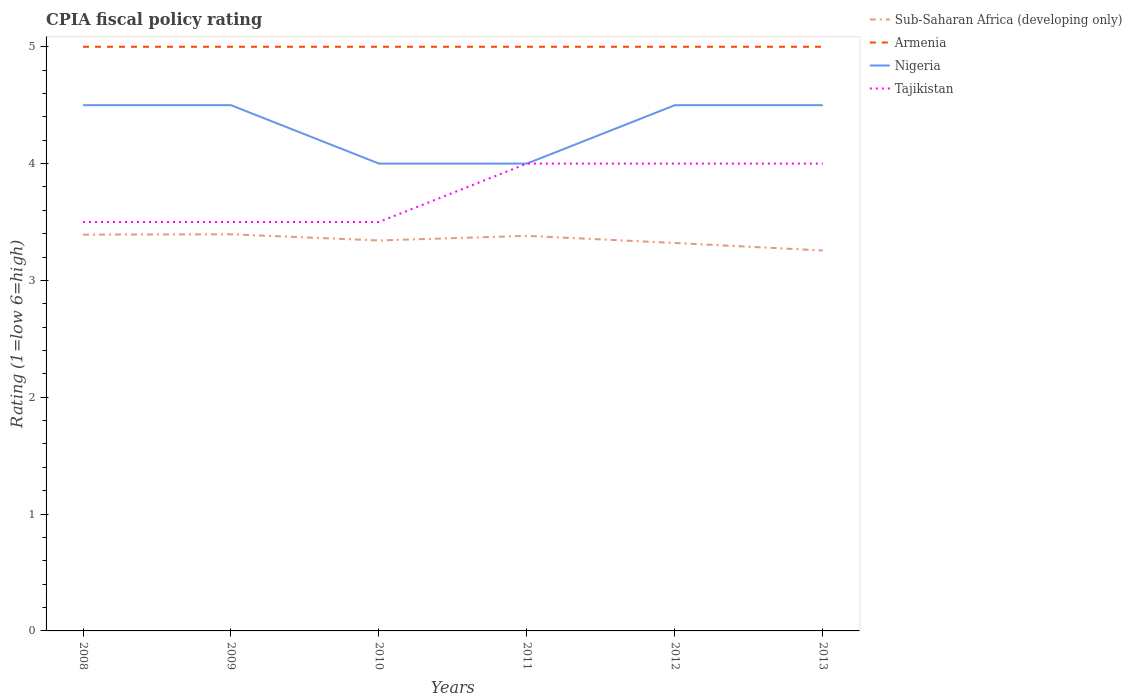How many different coloured lines are there?
Your answer should be compact. 4. Across all years, what is the maximum CPIA rating in Armenia?
Offer a very short reply. 5. In which year was the CPIA rating in Armenia maximum?
Give a very brief answer. 2008. What is the total CPIA rating in Sub-Saharan Africa (developing only) in the graph?
Provide a short and direct response. 0.13. What is the difference between the highest and the second highest CPIA rating in Tajikistan?
Your response must be concise. 0.5. What is the difference between the highest and the lowest CPIA rating in Tajikistan?
Offer a terse response. 3. How many lines are there?
Your answer should be compact. 4. How many years are there in the graph?
Keep it short and to the point. 6. What is the difference between two consecutive major ticks on the Y-axis?
Offer a very short reply. 1. Are the values on the major ticks of Y-axis written in scientific E-notation?
Ensure brevity in your answer.  No. How many legend labels are there?
Provide a short and direct response. 4. How are the legend labels stacked?
Offer a very short reply. Vertical. What is the title of the graph?
Make the answer very short. CPIA fiscal policy rating. What is the label or title of the X-axis?
Offer a very short reply. Years. What is the label or title of the Y-axis?
Offer a terse response. Rating (1=low 6=high). What is the Rating (1=low 6=high) of Sub-Saharan Africa (developing only) in 2008?
Your response must be concise. 3.39. What is the Rating (1=low 6=high) of Armenia in 2008?
Your response must be concise. 5. What is the Rating (1=low 6=high) of Sub-Saharan Africa (developing only) in 2009?
Your answer should be compact. 3.39. What is the Rating (1=low 6=high) of Armenia in 2009?
Your answer should be very brief. 5. What is the Rating (1=low 6=high) in Nigeria in 2009?
Your response must be concise. 4.5. What is the Rating (1=low 6=high) in Sub-Saharan Africa (developing only) in 2010?
Your response must be concise. 3.34. What is the Rating (1=low 6=high) of Sub-Saharan Africa (developing only) in 2011?
Your response must be concise. 3.38. What is the Rating (1=low 6=high) of Tajikistan in 2011?
Offer a very short reply. 4. What is the Rating (1=low 6=high) in Sub-Saharan Africa (developing only) in 2012?
Provide a short and direct response. 3.32. What is the Rating (1=low 6=high) of Armenia in 2012?
Your answer should be very brief. 5. What is the Rating (1=low 6=high) in Nigeria in 2012?
Provide a succinct answer. 4.5. What is the Rating (1=low 6=high) of Tajikistan in 2012?
Your response must be concise. 4. What is the Rating (1=low 6=high) in Sub-Saharan Africa (developing only) in 2013?
Offer a terse response. 3.26. What is the Rating (1=low 6=high) in Armenia in 2013?
Keep it short and to the point. 5. Across all years, what is the maximum Rating (1=low 6=high) in Sub-Saharan Africa (developing only)?
Your answer should be compact. 3.39. Across all years, what is the minimum Rating (1=low 6=high) in Sub-Saharan Africa (developing only)?
Ensure brevity in your answer.  3.26. Across all years, what is the minimum Rating (1=low 6=high) of Nigeria?
Your answer should be compact. 4. Across all years, what is the minimum Rating (1=low 6=high) of Tajikistan?
Your answer should be compact. 3.5. What is the total Rating (1=low 6=high) of Sub-Saharan Africa (developing only) in the graph?
Keep it short and to the point. 20.09. What is the total Rating (1=low 6=high) in Nigeria in the graph?
Your answer should be compact. 26. What is the total Rating (1=low 6=high) of Tajikistan in the graph?
Provide a succinct answer. 22.5. What is the difference between the Rating (1=low 6=high) in Sub-Saharan Africa (developing only) in 2008 and that in 2009?
Your response must be concise. -0. What is the difference between the Rating (1=low 6=high) in Nigeria in 2008 and that in 2009?
Your answer should be compact. 0. What is the difference between the Rating (1=low 6=high) in Tajikistan in 2008 and that in 2009?
Your response must be concise. 0. What is the difference between the Rating (1=low 6=high) of Sub-Saharan Africa (developing only) in 2008 and that in 2010?
Offer a terse response. 0.05. What is the difference between the Rating (1=low 6=high) in Armenia in 2008 and that in 2010?
Offer a very short reply. 0. What is the difference between the Rating (1=low 6=high) of Tajikistan in 2008 and that in 2010?
Offer a very short reply. 0. What is the difference between the Rating (1=low 6=high) of Sub-Saharan Africa (developing only) in 2008 and that in 2011?
Your answer should be compact. 0.01. What is the difference between the Rating (1=low 6=high) in Armenia in 2008 and that in 2011?
Your answer should be compact. 0. What is the difference between the Rating (1=low 6=high) of Sub-Saharan Africa (developing only) in 2008 and that in 2012?
Your response must be concise. 0.07. What is the difference between the Rating (1=low 6=high) in Sub-Saharan Africa (developing only) in 2008 and that in 2013?
Your answer should be very brief. 0.14. What is the difference between the Rating (1=low 6=high) in Armenia in 2008 and that in 2013?
Offer a terse response. 0. What is the difference between the Rating (1=low 6=high) in Tajikistan in 2008 and that in 2013?
Provide a short and direct response. -0.5. What is the difference between the Rating (1=low 6=high) of Sub-Saharan Africa (developing only) in 2009 and that in 2010?
Keep it short and to the point. 0.05. What is the difference between the Rating (1=low 6=high) of Nigeria in 2009 and that in 2010?
Your response must be concise. 0.5. What is the difference between the Rating (1=low 6=high) of Sub-Saharan Africa (developing only) in 2009 and that in 2011?
Your response must be concise. 0.01. What is the difference between the Rating (1=low 6=high) in Armenia in 2009 and that in 2011?
Provide a short and direct response. 0. What is the difference between the Rating (1=low 6=high) in Sub-Saharan Africa (developing only) in 2009 and that in 2012?
Your response must be concise. 0.07. What is the difference between the Rating (1=low 6=high) in Armenia in 2009 and that in 2012?
Your response must be concise. 0. What is the difference between the Rating (1=low 6=high) in Sub-Saharan Africa (developing only) in 2009 and that in 2013?
Offer a terse response. 0.14. What is the difference between the Rating (1=low 6=high) of Armenia in 2009 and that in 2013?
Your answer should be very brief. 0. What is the difference between the Rating (1=low 6=high) of Nigeria in 2009 and that in 2013?
Offer a terse response. 0. What is the difference between the Rating (1=low 6=high) of Tajikistan in 2009 and that in 2013?
Keep it short and to the point. -0.5. What is the difference between the Rating (1=low 6=high) of Sub-Saharan Africa (developing only) in 2010 and that in 2011?
Provide a short and direct response. -0.04. What is the difference between the Rating (1=low 6=high) in Sub-Saharan Africa (developing only) in 2010 and that in 2012?
Give a very brief answer. 0.02. What is the difference between the Rating (1=low 6=high) in Nigeria in 2010 and that in 2012?
Provide a succinct answer. -0.5. What is the difference between the Rating (1=low 6=high) in Tajikistan in 2010 and that in 2012?
Give a very brief answer. -0.5. What is the difference between the Rating (1=low 6=high) in Sub-Saharan Africa (developing only) in 2010 and that in 2013?
Your answer should be very brief. 0.09. What is the difference between the Rating (1=low 6=high) in Armenia in 2010 and that in 2013?
Keep it short and to the point. 0. What is the difference between the Rating (1=low 6=high) in Nigeria in 2010 and that in 2013?
Ensure brevity in your answer.  -0.5. What is the difference between the Rating (1=low 6=high) of Sub-Saharan Africa (developing only) in 2011 and that in 2012?
Your answer should be compact. 0.06. What is the difference between the Rating (1=low 6=high) of Nigeria in 2011 and that in 2012?
Keep it short and to the point. -0.5. What is the difference between the Rating (1=low 6=high) in Tajikistan in 2011 and that in 2012?
Ensure brevity in your answer.  0. What is the difference between the Rating (1=low 6=high) in Sub-Saharan Africa (developing only) in 2011 and that in 2013?
Your answer should be compact. 0.13. What is the difference between the Rating (1=low 6=high) of Sub-Saharan Africa (developing only) in 2012 and that in 2013?
Your answer should be very brief. 0.06. What is the difference between the Rating (1=low 6=high) of Armenia in 2012 and that in 2013?
Your answer should be very brief. 0. What is the difference between the Rating (1=low 6=high) in Sub-Saharan Africa (developing only) in 2008 and the Rating (1=low 6=high) in Armenia in 2009?
Make the answer very short. -1.61. What is the difference between the Rating (1=low 6=high) in Sub-Saharan Africa (developing only) in 2008 and the Rating (1=low 6=high) in Nigeria in 2009?
Offer a very short reply. -1.11. What is the difference between the Rating (1=low 6=high) of Sub-Saharan Africa (developing only) in 2008 and the Rating (1=low 6=high) of Tajikistan in 2009?
Provide a short and direct response. -0.11. What is the difference between the Rating (1=low 6=high) in Armenia in 2008 and the Rating (1=low 6=high) in Nigeria in 2009?
Your answer should be compact. 0.5. What is the difference between the Rating (1=low 6=high) in Sub-Saharan Africa (developing only) in 2008 and the Rating (1=low 6=high) in Armenia in 2010?
Offer a terse response. -1.61. What is the difference between the Rating (1=low 6=high) in Sub-Saharan Africa (developing only) in 2008 and the Rating (1=low 6=high) in Nigeria in 2010?
Ensure brevity in your answer.  -0.61. What is the difference between the Rating (1=low 6=high) of Sub-Saharan Africa (developing only) in 2008 and the Rating (1=low 6=high) of Tajikistan in 2010?
Your answer should be very brief. -0.11. What is the difference between the Rating (1=low 6=high) of Sub-Saharan Africa (developing only) in 2008 and the Rating (1=low 6=high) of Armenia in 2011?
Offer a very short reply. -1.61. What is the difference between the Rating (1=low 6=high) in Sub-Saharan Africa (developing only) in 2008 and the Rating (1=low 6=high) in Nigeria in 2011?
Offer a very short reply. -0.61. What is the difference between the Rating (1=low 6=high) of Sub-Saharan Africa (developing only) in 2008 and the Rating (1=low 6=high) of Tajikistan in 2011?
Provide a short and direct response. -0.61. What is the difference between the Rating (1=low 6=high) of Armenia in 2008 and the Rating (1=low 6=high) of Nigeria in 2011?
Provide a succinct answer. 1. What is the difference between the Rating (1=low 6=high) in Nigeria in 2008 and the Rating (1=low 6=high) in Tajikistan in 2011?
Offer a terse response. 0.5. What is the difference between the Rating (1=low 6=high) of Sub-Saharan Africa (developing only) in 2008 and the Rating (1=low 6=high) of Armenia in 2012?
Offer a terse response. -1.61. What is the difference between the Rating (1=low 6=high) of Sub-Saharan Africa (developing only) in 2008 and the Rating (1=low 6=high) of Nigeria in 2012?
Your answer should be compact. -1.11. What is the difference between the Rating (1=low 6=high) in Sub-Saharan Africa (developing only) in 2008 and the Rating (1=low 6=high) in Tajikistan in 2012?
Your answer should be compact. -0.61. What is the difference between the Rating (1=low 6=high) of Armenia in 2008 and the Rating (1=low 6=high) of Nigeria in 2012?
Provide a short and direct response. 0.5. What is the difference between the Rating (1=low 6=high) in Armenia in 2008 and the Rating (1=low 6=high) in Tajikistan in 2012?
Ensure brevity in your answer.  1. What is the difference between the Rating (1=low 6=high) of Sub-Saharan Africa (developing only) in 2008 and the Rating (1=low 6=high) of Armenia in 2013?
Ensure brevity in your answer.  -1.61. What is the difference between the Rating (1=low 6=high) of Sub-Saharan Africa (developing only) in 2008 and the Rating (1=low 6=high) of Nigeria in 2013?
Make the answer very short. -1.11. What is the difference between the Rating (1=low 6=high) in Sub-Saharan Africa (developing only) in 2008 and the Rating (1=low 6=high) in Tajikistan in 2013?
Make the answer very short. -0.61. What is the difference between the Rating (1=low 6=high) in Sub-Saharan Africa (developing only) in 2009 and the Rating (1=low 6=high) in Armenia in 2010?
Give a very brief answer. -1.61. What is the difference between the Rating (1=low 6=high) of Sub-Saharan Africa (developing only) in 2009 and the Rating (1=low 6=high) of Nigeria in 2010?
Give a very brief answer. -0.61. What is the difference between the Rating (1=low 6=high) in Sub-Saharan Africa (developing only) in 2009 and the Rating (1=low 6=high) in Tajikistan in 2010?
Your response must be concise. -0.11. What is the difference between the Rating (1=low 6=high) in Armenia in 2009 and the Rating (1=low 6=high) in Tajikistan in 2010?
Ensure brevity in your answer.  1.5. What is the difference between the Rating (1=low 6=high) of Nigeria in 2009 and the Rating (1=low 6=high) of Tajikistan in 2010?
Ensure brevity in your answer.  1. What is the difference between the Rating (1=low 6=high) in Sub-Saharan Africa (developing only) in 2009 and the Rating (1=low 6=high) in Armenia in 2011?
Offer a terse response. -1.61. What is the difference between the Rating (1=low 6=high) in Sub-Saharan Africa (developing only) in 2009 and the Rating (1=low 6=high) in Nigeria in 2011?
Provide a short and direct response. -0.61. What is the difference between the Rating (1=low 6=high) of Sub-Saharan Africa (developing only) in 2009 and the Rating (1=low 6=high) of Tajikistan in 2011?
Give a very brief answer. -0.61. What is the difference between the Rating (1=low 6=high) in Armenia in 2009 and the Rating (1=low 6=high) in Nigeria in 2011?
Make the answer very short. 1. What is the difference between the Rating (1=low 6=high) of Nigeria in 2009 and the Rating (1=low 6=high) of Tajikistan in 2011?
Your response must be concise. 0.5. What is the difference between the Rating (1=low 6=high) in Sub-Saharan Africa (developing only) in 2009 and the Rating (1=low 6=high) in Armenia in 2012?
Offer a very short reply. -1.61. What is the difference between the Rating (1=low 6=high) in Sub-Saharan Africa (developing only) in 2009 and the Rating (1=low 6=high) in Nigeria in 2012?
Keep it short and to the point. -1.11. What is the difference between the Rating (1=low 6=high) in Sub-Saharan Africa (developing only) in 2009 and the Rating (1=low 6=high) in Tajikistan in 2012?
Your answer should be compact. -0.61. What is the difference between the Rating (1=low 6=high) of Armenia in 2009 and the Rating (1=low 6=high) of Tajikistan in 2012?
Offer a very short reply. 1. What is the difference between the Rating (1=low 6=high) in Sub-Saharan Africa (developing only) in 2009 and the Rating (1=low 6=high) in Armenia in 2013?
Keep it short and to the point. -1.61. What is the difference between the Rating (1=low 6=high) in Sub-Saharan Africa (developing only) in 2009 and the Rating (1=low 6=high) in Nigeria in 2013?
Make the answer very short. -1.11. What is the difference between the Rating (1=low 6=high) of Sub-Saharan Africa (developing only) in 2009 and the Rating (1=low 6=high) of Tajikistan in 2013?
Your response must be concise. -0.61. What is the difference between the Rating (1=low 6=high) of Armenia in 2009 and the Rating (1=low 6=high) of Tajikistan in 2013?
Your response must be concise. 1. What is the difference between the Rating (1=low 6=high) in Sub-Saharan Africa (developing only) in 2010 and the Rating (1=low 6=high) in Armenia in 2011?
Your answer should be very brief. -1.66. What is the difference between the Rating (1=low 6=high) of Sub-Saharan Africa (developing only) in 2010 and the Rating (1=low 6=high) of Nigeria in 2011?
Provide a short and direct response. -0.66. What is the difference between the Rating (1=low 6=high) of Sub-Saharan Africa (developing only) in 2010 and the Rating (1=low 6=high) of Tajikistan in 2011?
Your answer should be compact. -0.66. What is the difference between the Rating (1=low 6=high) in Armenia in 2010 and the Rating (1=low 6=high) in Nigeria in 2011?
Keep it short and to the point. 1. What is the difference between the Rating (1=low 6=high) of Nigeria in 2010 and the Rating (1=low 6=high) of Tajikistan in 2011?
Give a very brief answer. 0. What is the difference between the Rating (1=low 6=high) in Sub-Saharan Africa (developing only) in 2010 and the Rating (1=low 6=high) in Armenia in 2012?
Keep it short and to the point. -1.66. What is the difference between the Rating (1=low 6=high) of Sub-Saharan Africa (developing only) in 2010 and the Rating (1=low 6=high) of Nigeria in 2012?
Provide a succinct answer. -1.16. What is the difference between the Rating (1=low 6=high) in Sub-Saharan Africa (developing only) in 2010 and the Rating (1=low 6=high) in Tajikistan in 2012?
Offer a very short reply. -0.66. What is the difference between the Rating (1=low 6=high) in Armenia in 2010 and the Rating (1=low 6=high) in Tajikistan in 2012?
Give a very brief answer. 1. What is the difference between the Rating (1=low 6=high) in Nigeria in 2010 and the Rating (1=low 6=high) in Tajikistan in 2012?
Ensure brevity in your answer.  0. What is the difference between the Rating (1=low 6=high) in Sub-Saharan Africa (developing only) in 2010 and the Rating (1=low 6=high) in Armenia in 2013?
Keep it short and to the point. -1.66. What is the difference between the Rating (1=low 6=high) of Sub-Saharan Africa (developing only) in 2010 and the Rating (1=low 6=high) of Nigeria in 2013?
Your response must be concise. -1.16. What is the difference between the Rating (1=low 6=high) in Sub-Saharan Africa (developing only) in 2010 and the Rating (1=low 6=high) in Tajikistan in 2013?
Keep it short and to the point. -0.66. What is the difference between the Rating (1=low 6=high) in Armenia in 2010 and the Rating (1=low 6=high) in Tajikistan in 2013?
Keep it short and to the point. 1. What is the difference between the Rating (1=low 6=high) of Nigeria in 2010 and the Rating (1=low 6=high) of Tajikistan in 2013?
Offer a very short reply. 0. What is the difference between the Rating (1=low 6=high) of Sub-Saharan Africa (developing only) in 2011 and the Rating (1=low 6=high) of Armenia in 2012?
Offer a very short reply. -1.62. What is the difference between the Rating (1=low 6=high) in Sub-Saharan Africa (developing only) in 2011 and the Rating (1=low 6=high) in Nigeria in 2012?
Your response must be concise. -1.12. What is the difference between the Rating (1=low 6=high) in Sub-Saharan Africa (developing only) in 2011 and the Rating (1=low 6=high) in Tajikistan in 2012?
Your answer should be compact. -0.62. What is the difference between the Rating (1=low 6=high) of Armenia in 2011 and the Rating (1=low 6=high) of Tajikistan in 2012?
Give a very brief answer. 1. What is the difference between the Rating (1=low 6=high) of Sub-Saharan Africa (developing only) in 2011 and the Rating (1=low 6=high) of Armenia in 2013?
Ensure brevity in your answer.  -1.62. What is the difference between the Rating (1=low 6=high) in Sub-Saharan Africa (developing only) in 2011 and the Rating (1=low 6=high) in Nigeria in 2013?
Your answer should be compact. -1.12. What is the difference between the Rating (1=low 6=high) of Sub-Saharan Africa (developing only) in 2011 and the Rating (1=low 6=high) of Tajikistan in 2013?
Offer a terse response. -0.62. What is the difference between the Rating (1=low 6=high) of Armenia in 2011 and the Rating (1=low 6=high) of Tajikistan in 2013?
Offer a terse response. 1. What is the difference between the Rating (1=low 6=high) of Sub-Saharan Africa (developing only) in 2012 and the Rating (1=low 6=high) of Armenia in 2013?
Provide a short and direct response. -1.68. What is the difference between the Rating (1=low 6=high) in Sub-Saharan Africa (developing only) in 2012 and the Rating (1=low 6=high) in Nigeria in 2013?
Make the answer very short. -1.18. What is the difference between the Rating (1=low 6=high) of Sub-Saharan Africa (developing only) in 2012 and the Rating (1=low 6=high) of Tajikistan in 2013?
Your answer should be compact. -0.68. What is the difference between the Rating (1=low 6=high) of Armenia in 2012 and the Rating (1=low 6=high) of Tajikistan in 2013?
Provide a succinct answer. 1. What is the difference between the Rating (1=low 6=high) of Nigeria in 2012 and the Rating (1=low 6=high) of Tajikistan in 2013?
Offer a very short reply. 0.5. What is the average Rating (1=low 6=high) in Sub-Saharan Africa (developing only) per year?
Give a very brief answer. 3.35. What is the average Rating (1=low 6=high) of Armenia per year?
Provide a short and direct response. 5. What is the average Rating (1=low 6=high) of Nigeria per year?
Make the answer very short. 4.33. What is the average Rating (1=low 6=high) of Tajikistan per year?
Provide a short and direct response. 3.75. In the year 2008, what is the difference between the Rating (1=low 6=high) in Sub-Saharan Africa (developing only) and Rating (1=low 6=high) in Armenia?
Offer a terse response. -1.61. In the year 2008, what is the difference between the Rating (1=low 6=high) in Sub-Saharan Africa (developing only) and Rating (1=low 6=high) in Nigeria?
Your response must be concise. -1.11. In the year 2008, what is the difference between the Rating (1=low 6=high) in Sub-Saharan Africa (developing only) and Rating (1=low 6=high) in Tajikistan?
Provide a succinct answer. -0.11. In the year 2008, what is the difference between the Rating (1=low 6=high) in Armenia and Rating (1=low 6=high) in Tajikistan?
Offer a terse response. 1.5. In the year 2008, what is the difference between the Rating (1=low 6=high) of Nigeria and Rating (1=low 6=high) of Tajikistan?
Your answer should be compact. 1. In the year 2009, what is the difference between the Rating (1=low 6=high) in Sub-Saharan Africa (developing only) and Rating (1=low 6=high) in Armenia?
Give a very brief answer. -1.61. In the year 2009, what is the difference between the Rating (1=low 6=high) of Sub-Saharan Africa (developing only) and Rating (1=low 6=high) of Nigeria?
Offer a terse response. -1.11. In the year 2009, what is the difference between the Rating (1=low 6=high) in Sub-Saharan Africa (developing only) and Rating (1=low 6=high) in Tajikistan?
Make the answer very short. -0.11. In the year 2009, what is the difference between the Rating (1=low 6=high) in Armenia and Rating (1=low 6=high) in Nigeria?
Make the answer very short. 0.5. In the year 2009, what is the difference between the Rating (1=low 6=high) in Armenia and Rating (1=low 6=high) in Tajikistan?
Ensure brevity in your answer.  1.5. In the year 2009, what is the difference between the Rating (1=low 6=high) in Nigeria and Rating (1=low 6=high) in Tajikistan?
Your response must be concise. 1. In the year 2010, what is the difference between the Rating (1=low 6=high) of Sub-Saharan Africa (developing only) and Rating (1=low 6=high) of Armenia?
Provide a succinct answer. -1.66. In the year 2010, what is the difference between the Rating (1=low 6=high) of Sub-Saharan Africa (developing only) and Rating (1=low 6=high) of Nigeria?
Provide a succinct answer. -0.66. In the year 2010, what is the difference between the Rating (1=low 6=high) in Sub-Saharan Africa (developing only) and Rating (1=low 6=high) in Tajikistan?
Keep it short and to the point. -0.16. In the year 2010, what is the difference between the Rating (1=low 6=high) of Armenia and Rating (1=low 6=high) of Tajikistan?
Offer a terse response. 1.5. In the year 2010, what is the difference between the Rating (1=low 6=high) in Nigeria and Rating (1=low 6=high) in Tajikistan?
Your response must be concise. 0.5. In the year 2011, what is the difference between the Rating (1=low 6=high) of Sub-Saharan Africa (developing only) and Rating (1=low 6=high) of Armenia?
Give a very brief answer. -1.62. In the year 2011, what is the difference between the Rating (1=low 6=high) of Sub-Saharan Africa (developing only) and Rating (1=low 6=high) of Nigeria?
Provide a short and direct response. -0.62. In the year 2011, what is the difference between the Rating (1=low 6=high) of Sub-Saharan Africa (developing only) and Rating (1=low 6=high) of Tajikistan?
Your answer should be very brief. -0.62. In the year 2011, what is the difference between the Rating (1=low 6=high) in Nigeria and Rating (1=low 6=high) in Tajikistan?
Your answer should be compact. 0. In the year 2012, what is the difference between the Rating (1=low 6=high) in Sub-Saharan Africa (developing only) and Rating (1=low 6=high) in Armenia?
Ensure brevity in your answer.  -1.68. In the year 2012, what is the difference between the Rating (1=low 6=high) of Sub-Saharan Africa (developing only) and Rating (1=low 6=high) of Nigeria?
Provide a short and direct response. -1.18. In the year 2012, what is the difference between the Rating (1=low 6=high) of Sub-Saharan Africa (developing only) and Rating (1=low 6=high) of Tajikistan?
Offer a very short reply. -0.68. In the year 2012, what is the difference between the Rating (1=low 6=high) in Armenia and Rating (1=low 6=high) in Nigeria?
Your answer should be very brief. 0.5. In the year 2013, what is the difference between the Rating (1=low 6=high) in Sub-Saharan Africa (developing only) and Rating (1=low 6=high) in Armenia?
Offer a terse response. -1.74. In the year 2013, what is the difference between the Rating (1=low 6=high) in Sub-Saharan Africa (developing only) and Rating (1=low 6=high) in Nigeria?
Ensure brevity in your answer.  -1.24. In the year 2013, what is the difference between the Rating (1=low 6=high) of Sub-Saharan Africa (developing only) and Rating (1=low 6=high) of Tajikistan?
Ensure brevity in your answer.  -0.74. In the year 2013, what is the difference between the Rating (1=low 6=high) of Armenia and Rating (1=low 6=high) of Tajikistan?
Your answer should be very brief. 1. What is the ratio of the Rating (1=low 6=high) in Sub-Saharan Africa (developing only) in 2008 to that in 2009?
Offer a very short reply. 1. What is the ratio of the Rating (1=low 6=high) in Armenia in 2008 to that in 2009?
Your answer should be very brief. 1. What is the ratio of the Rating (1=low 6=high) of Nigeria in 2008 to that in 2009?
Provide a succinct answer. 1. What is the ratio of the Rating (1=low 6=high) of Sub-Saharan Africa (developing only) in 2008 to that in 2010?
Offer a very short reply. 1.01. What is the ratio of the Rating (1=low 6=high) in Armenia in 2008 to that in 2010?
Offer a very short reply. 1. What is the ratio of the Rating (1=low 6=high) in Tajikistan in 2008 to that in 2011?
Your response must be concise. 0.88. What is the ratio of the Rating (1=low 6=high) in Sub-Saharan Africa (developing only) in 2008 to that in 2012?
Ensure brevity in your answer.  1.02. What is the ratio of the Rating (1=low 6=high) of Tajikistan in 2008 to that in 2012?
Make the answer very short. 0.88. What is the ratio of the Rating (1=low 6=high) of Sub-Saharan Africa (developing only) in 2008 to that in 2013?
Give a very brief answer. 1.04. What is the ratio of the Rating (1=low 6=high) in Nigeria in 2008 to that in 2013?
Offer a terse response. 1. What is the ratio of the Rating (1=low 6=high) in Sub-Saharan Africa (developing only) in 2009 to that in 2010?
Make the answer very short. 1.02. What is the ratio of the Rating (1=low 6=high) in Nigeria in 2009 to that in 2010?
Offer a terse response. 1.12. What is the ratio of the Rating (1=low 6=high) in Sub-Saharan Africa (developing only) in 2009 to that in 2011?
Your answer should be compact. 1. What is the ratio of the Rating (1=low 6=high) in Armenia in 2009 to that in 2011?
Provide a succinct answer. 1. What is the ratio of the Rating (1=low 6=high) of Tajikistan in 2009 to that in 2011?
Your response must be concise. 0.88. What is the ratio of the Rating (1=low 6=high) of Sub-Saharan Africa (developing only) in 2009 to that in 2012?
Make the answer very short. 1.02. What is the ratio of the Rating (1=low 6=high) of Armenia in 2009 to that in 2012?
Ensure brevity in your answer.  1. What is the ratio of the Rating (1=low 6=high) of Nigeria in 2009 to that in 2012?
Your answer should be very brief. 1. What is the ratio of the Rating (1=low 6=high) of Sub-Saharan Africa (developing only) in 2009 to that in 2013?
Your answer should be very brief. 1.04. What is the ratio of the Rating (1=low 6=high) in Nigeria in 2009 to that in 2013?
Your response must be concise. 1. What is the ratio of the Rating (1=low 6=high) in Tajikistan in 2009 to that in 2013?
Make the answer very short. 0.88. What is the ratio of the Rating (1=low 6=high) of Sub-Saharan Africa (developing only) in 2010 to that in 2011?
Your response must be concise. 0.99. What is the ratio of the Rating (1=low 6=high) in Armenia in 2010 to that in 2011?
Your answer should be very brief. 1. What is the ratio of the Rating (1=low 6=high) of Nigeria in 2010 to that in 2011?
Provide a succinct answer. 1. What is the ratio of the Rating (1=low 6=high) of Tajikistan in 2010 to that in 2011?
Make the answer very short. 0.88. What is the ratio of the Rating (1=low 6=high) in Armenia in 2010 to that in 2012?
Keep it short and to the point. 1. What is the ratio of the Rating (1=low 6=high) of Nigeria in 2010 to that in 2012?
Ensure brevity in your answer.  0.89. What is the ratio of the Rating (1=low 6=high) of Tajikistan in 2010 to that in 2012?
Make the answer very short. 0.88. What is the ratio of the Rating (1=low 6=high) of Sub-Saharan Africa (developing only) in 2010 to that in 2013?
Offer a very short reply. 1.03. What is the ratio of the Rating (1=low 6=high) in Nigeria in 2010 to that in 2013?
Ensure brevity in your answer.  0.89. What is the ratio of the Rating (1=low 6=high) of Sub-Saharan Africa (developing only) in 2011 to that in 2012?
Offer a very short reply. 1.02. What is the ratio of the Rating (1=low 6=high) in Armenia in 2011 to that in 2012?
Your answer should be compact. 1. What is the ratio of the Rating (1=low 6=high) in Sub-Saharan Africa (developing only) in 2011 to that in 2013?
Offer a very short reply. 1.04. What is the ratio of the Rating (1=low 6=high) in Nigeria in 2011 to that in 2013?
Provide a succinct answer. 0.89. What is the ratio of the Rating (1=low 6=high) in Tajikistan in 2011 to that in 2013?
Your answer should be compact. 1. What is the ratio of the Rating (1=low 6=high) in Sub-Saharan Africa (developing only) in 2012 to that in 2013?
Your answer should be very brief. 1.02. What is the ratio of the Rating (1=low 6=high) of Nigeria in 2012 to that in 2013?
Offer a terse response. 1. What is the difference between the highest and the second highest Rating (1=low 6=high) in Sub-Saharan Africa (developing only)?
Your answer should be very brief. 0. What is the difference between the highest and the second highest Rating (1=low 6=high) in Tajikistan?
Offer a very short reply. 0. What is the difference between the highest and the lowest Rating (1=low 6=high) of Sub-Saharan Africa (developing only)?
Your answer should be compact. 0.14. What is the difference between the highest and the lowest Rating (1=low 6=high) in Armenia?
Keep it short and to the point. 0. What is the difference between the highest and the lowest Rating (1=low 6=high) in Nigeria?
Offer a terse response. 0.5. What is the difference between the highest and the lowest Rating (1=low 6=high) in Tajikistan?
Your answer should be compact. 0.5. 